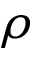<formula> <loc_0><loc_0><loc_500><loc_500>\rho</formula> 